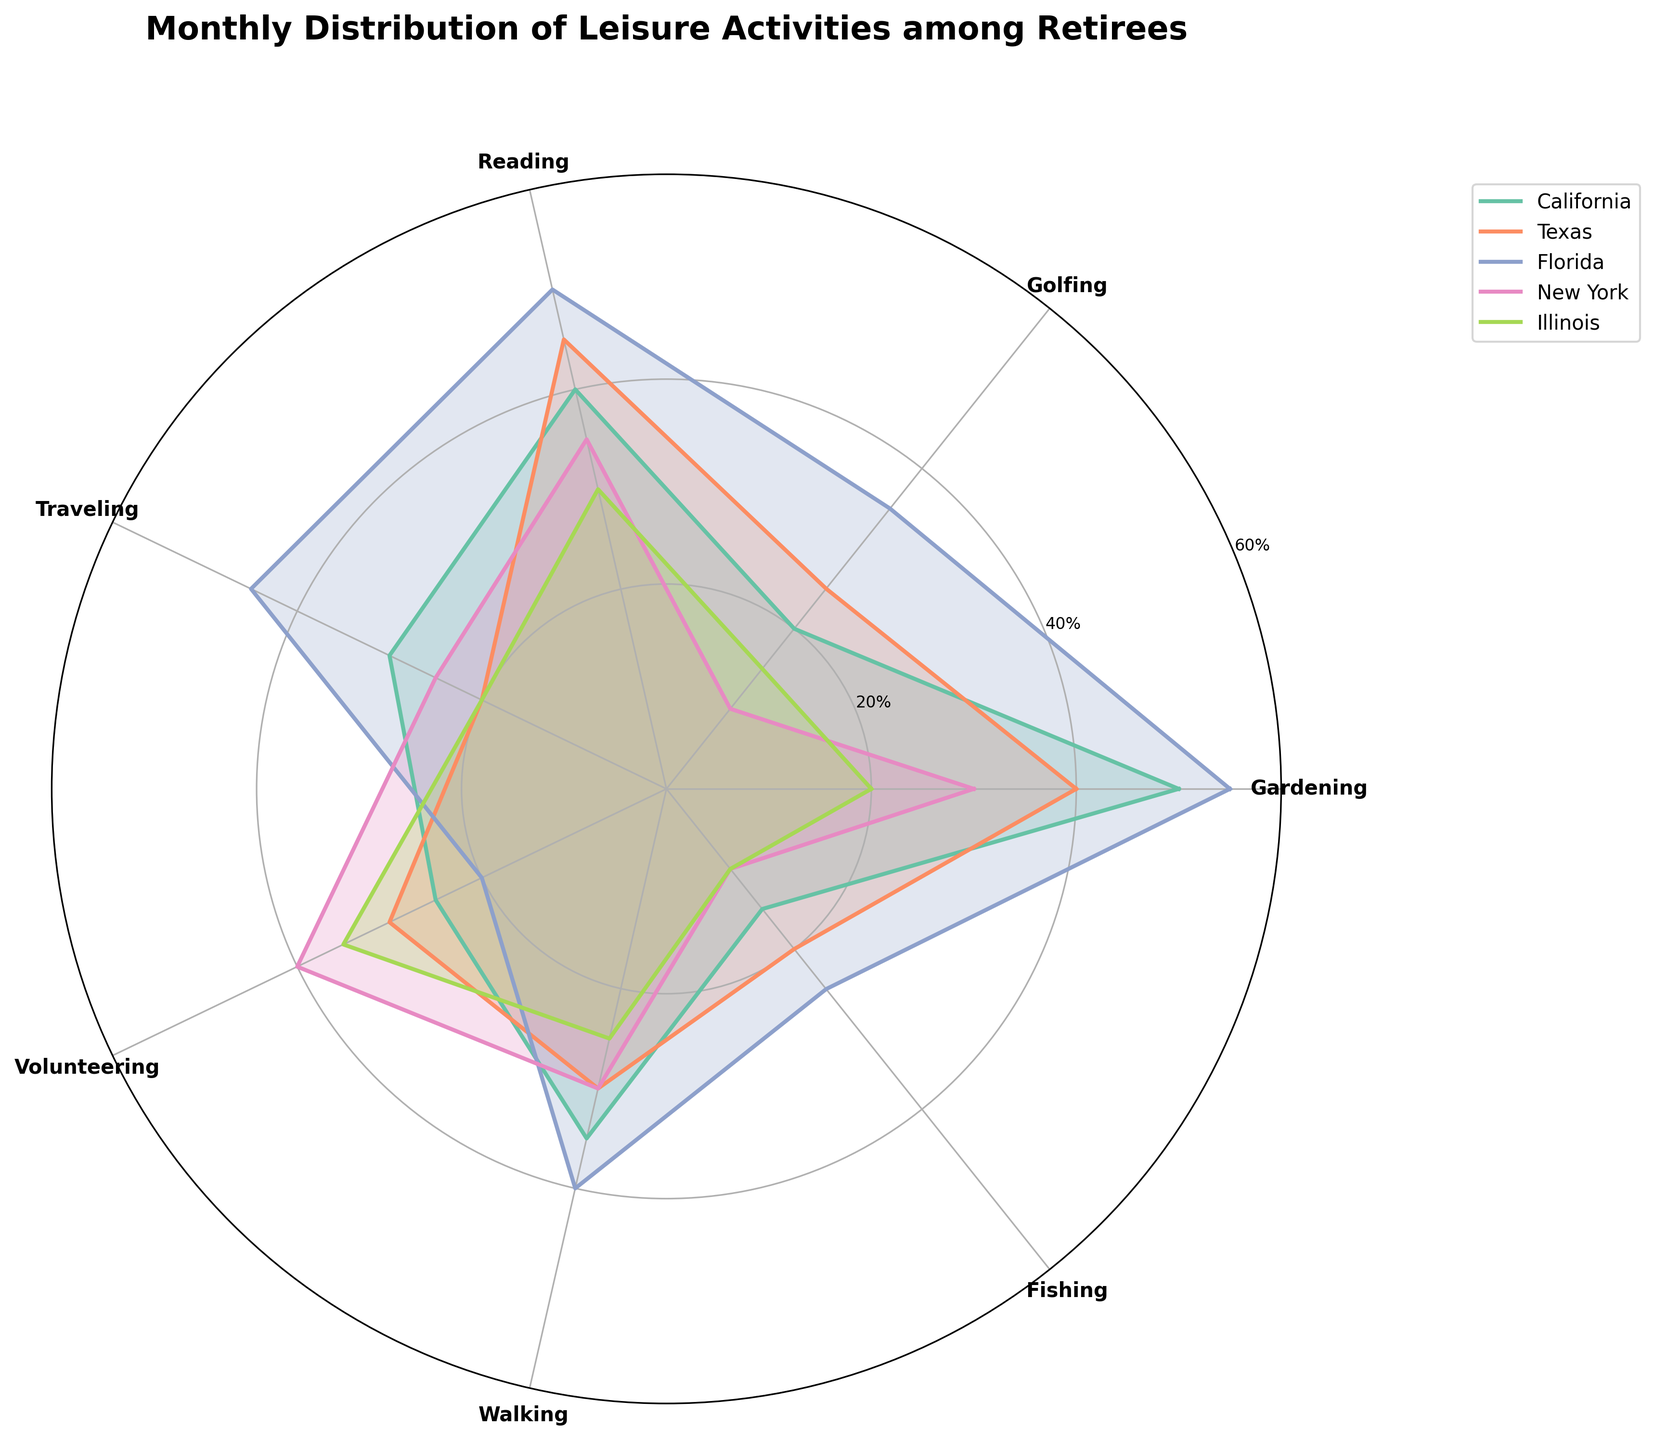What is the title of the figure? The title of the figure is the text at the top that describes what the chart represents.
Answer: Monthly Distribution of Leisure Activities among Retirees Which state has the highest percentage of retirees engaging in Gardening? From the figure, find the largest value in the Gardening category across the states.
Answer: Florida How many activities have their highest participant percentage in California? Look at the chart and count the number of activities for which the tallest segment belongs to California.
Answer: 1 Which activity has the lowest engagement in New York? Look at the radial lines for New York and identify the segment with the shortest length.
Answer: Fishing What is the combined percentage of retirees engaging in Golfing and Reading in Illinois? Find the percentage for Golfing and Reading in Illinois and add them together: 15 (Golfing) + 30 (Reading).
Answer: 45 On average, how many retirees in Texas participate in Traveling and Walking? Calculate the average by adding percentages for Traveling and Walking, then divide by 2: (20 + 30)/2.
Answer: 25 Which state has the least engagement in Fishing? Identify the point closest to the center of the polar plot in the Fishing category.
Answer: New York Compare Reading in California and Texas, which state has a higher percentage? Check the segments corresponding to Reading in California and Texas, compare their lengths.
Answer: Texas In which state do retirees participate in Volunteering the most? Identify the state with the largest segment in the Volunteering category.
Answer: New York What is the difference in percentage of retirees walking between California and Illinois? Subtract the walking percentage in Illinois from the walking percentage in California: 35 - 25.
Answer: 10 